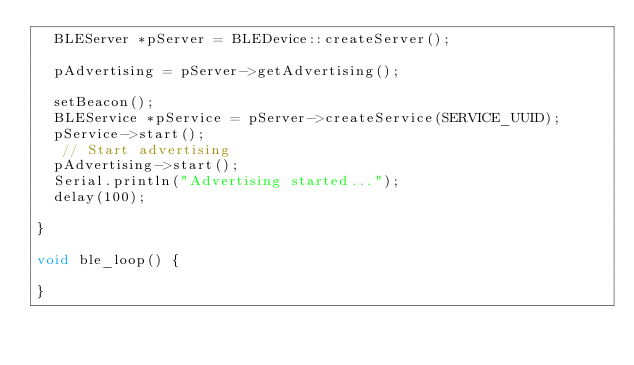<code> <loc_0><loc_0><loc_500><loc_500><_C++_>  BLEServer *pServer = BLEDevice::createServer();

  pAdvertising = pServer->getAdvertising();
  
  setBeacon();
  BLEService *pService = pServer->createService(SERVICE_UUID);
  pService->start();
   // Start advertising
  pAdvertising->start();
  Serial.println("Advertising started...");
  delay(100);
  
}

void ble_loop() {

}
</code> 